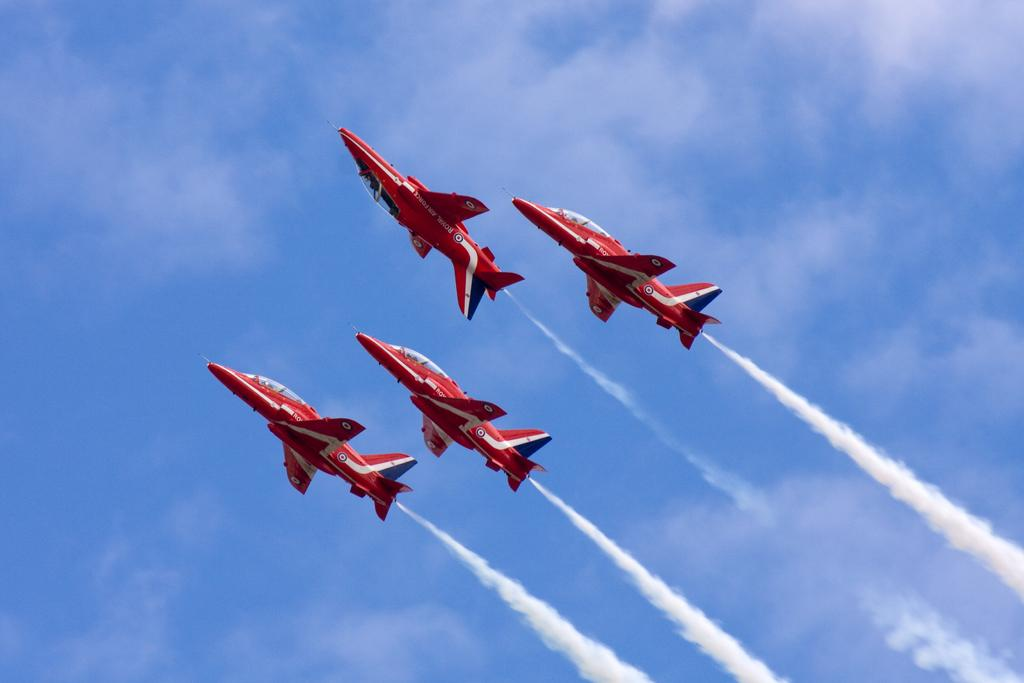What is the main subject of the image? The main subject of the image is four aircrafts in the center. What can be seen in the background of the image? The sky is visible in the background of the image, and there is some fog present. What type of lace can be seen on the aircrafts in the image? There is no lace present on the aircrafts in the image. Can you tell me how much honey is being produced by the aircrafts in the image? There is no mention of honey production in the image, as it features aircrafts and a background with sky and fog. 